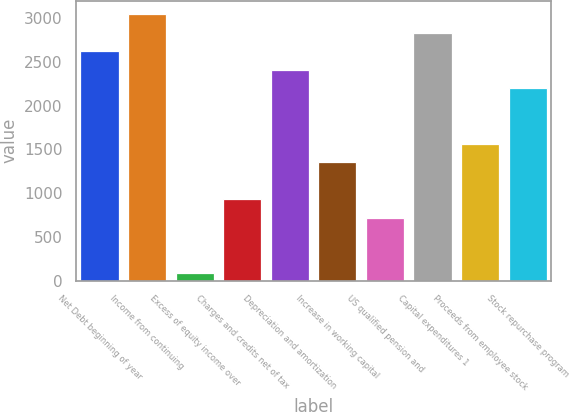<chart> <loc_0><loc_0><loc_500><loc_500><bar_chart><fcel>Net Debt beginning of year<fcel>Income from continuing<fcel>Excess of equity income over<fcel>Charges and credits net of tax<fcel>Depreciation and amortization<fcel>Increase in working capital<fcel>US qualified pension and<fcel>Capital expenditures 1<fcel>Proceeds from employee stock<fcel>Stock repurchase program<nl><fcel>2621.6<fcel>3044.2<fcel>86<fcel>931.2<fcel>2410.3<fcel>1353.8<fcel>719.9<fcel>2832.9<fcel>1565.1<fcel>2199<nl></chart> 